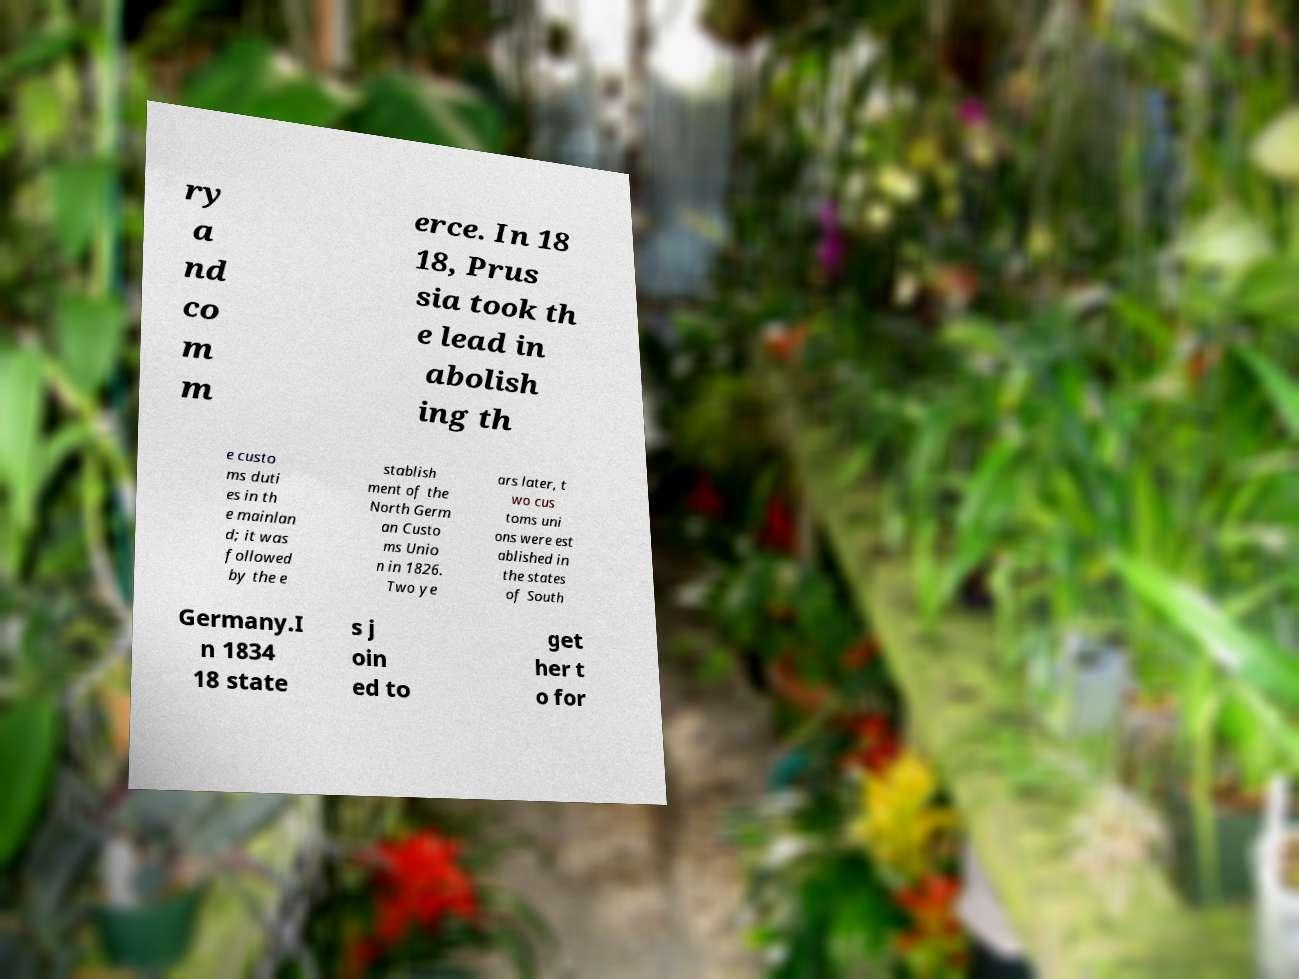For documentation purposes, I need the text within this image transcribed. Could you provide that? ry a nd co m m erce. In 18 18, Prus sia took th e lead in abolish ing th e custo ms duti es in th e mainlan d; it was followed by the e stablish ment of the North Germ an Custo ms Unio n in 1826. Two ye ars later, t wo cus toms uni ons were est ablished in the states of South Germany.I n 1834 18 state s j oin ed to get her t o for 